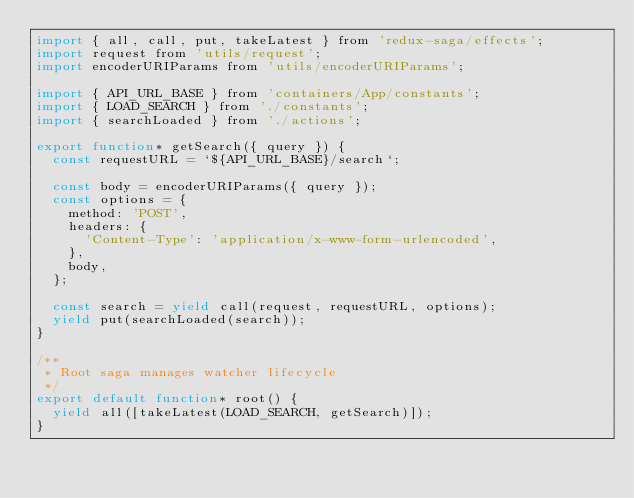Convert code to text. <code><loc_0><loc_0><loc_500><loc_500><_JavaScript_>import { all, call, put, takeLatest } from 'redux-saga/effects';
import request from 'utils/request';
import encoderURIParams from 'utils/encoderURIParams';

import { API_URL_BASE } from 'containers/App/constants';
import { LOAD_SEARCH } from './constants';
import { searchLoaded } from './actions';

export function* getSearch({ query }) {
  const requestURL = `${API_URL_BASE}/search`;

  const body = encoderURIParams({ query });
  const options = {
    method: 'POST',
    headers: {
      'Content-Type': 'application/x-www-form-urlencoded',
    },
    body,
  };

  const search = yield call(request, requestURL, options);
  yield put(searchLoaded(search));
}

/**
 * Root saga manages watcher lifecycle
 */
export default function* root() {
  yield all([takeLatest(LOAD_SEARCH, getSearch)]);
}
</code> 